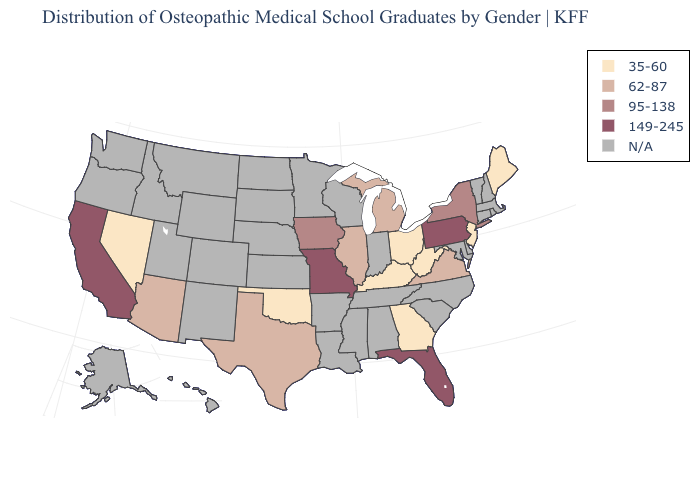Does the map have missing data?
Write a very short answer. Yes. What is the value of Georgia?
Be succinct. 35-60. Name the states that have a value in the range 62-87?
Quick response, please. Arizona, Illinois, Michigan, Texas, Virginia. Among the states that border California , which have the lowest value?
Short answer required. Nevada. Does Missouri have the lowest value in the USA?
Write a very short answer. No. Does the map have missing data?
Concise answer only. Yes. Does Maine have the highest value in the Northeast?
Write a very short answer. No. Which states have the lowest value in the West?
Short answer required. Nevada. Does the map have missing data?
Concise answer only. Yes. Name the states that have a value in the range 95-138?
Give a very brief answer. Iowa, New York. Does the first symbol in the legend represent the smallest category?
Quick response, please. Yes. What is the value of Oklahoma?
Concise answer only. 35-60. Name the states that have a value in the range 149-245?
Write a very short answer. California, Florida, Missouri, Pennsylvania. What is the value of Colorado?
Give a very brief answer. N/A. Which states have the lowest value in the USA?
Write a very short answer. Georgia, Kentucky, Maine, Nevada, New Jersey, Ohio, Oklahoma, West Virginia. 